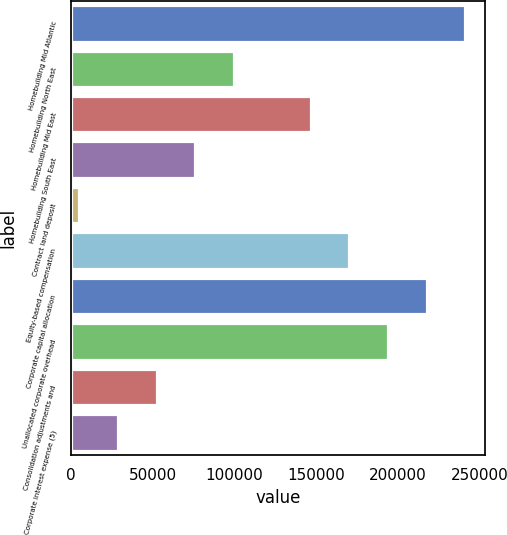<chart> <loc_0><loc_0><loc_500><loc_500><bar_chart><fcel>Homebuilding Mid Atlantic<fcel>Homebuilding North East<fcel>Homebuilding Mid East<fcel>Homebuilding South East<fcel>Contract land deposit<fcel>Equity-based compensation<fcel>Corporate capital allocation<fcel>Unallocated corporate overhead<fcel>Consolidation adjustments and<fcel>Corporate interest expense (5)<nl><fcel>240924<fcel>99569.4<fcel>146688<fcel>76010.3<fcel>5333<fcel>170247<fcel>217365<fcel>193806<fcel>52451.2<fcel>28892.1<nl></chart> 